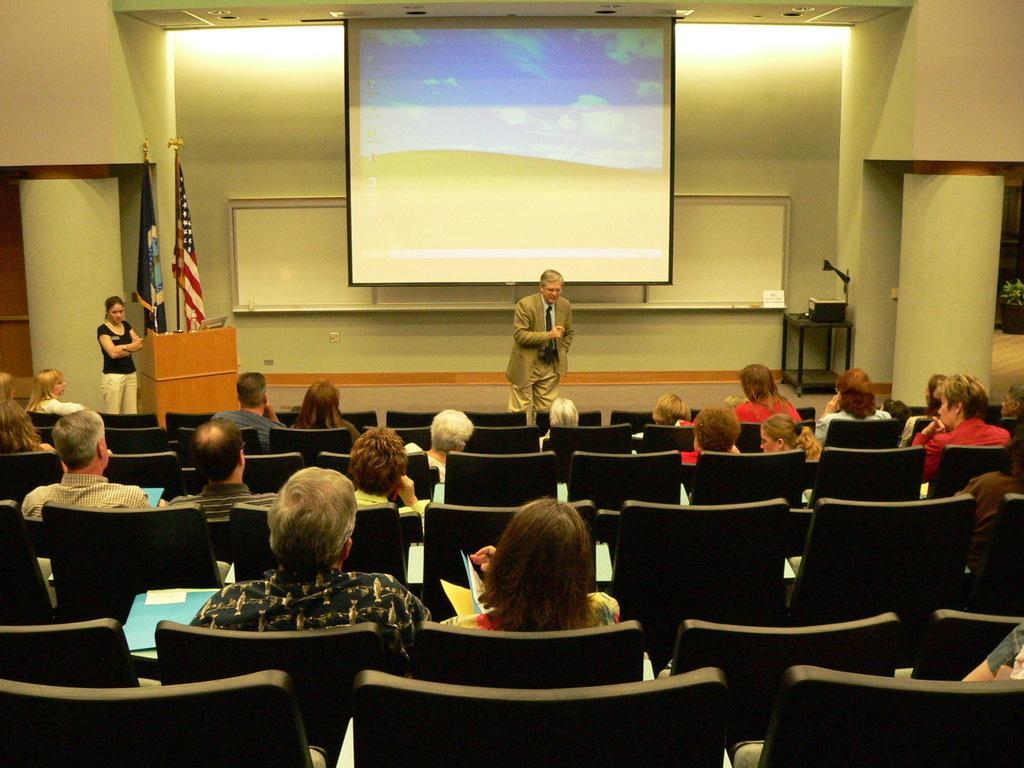Please provide a concise description of this image. There are many person sitting on chairs. There is a person standing on the back. There is a podium. There are two flags. In the background there is a wall and a screen. 